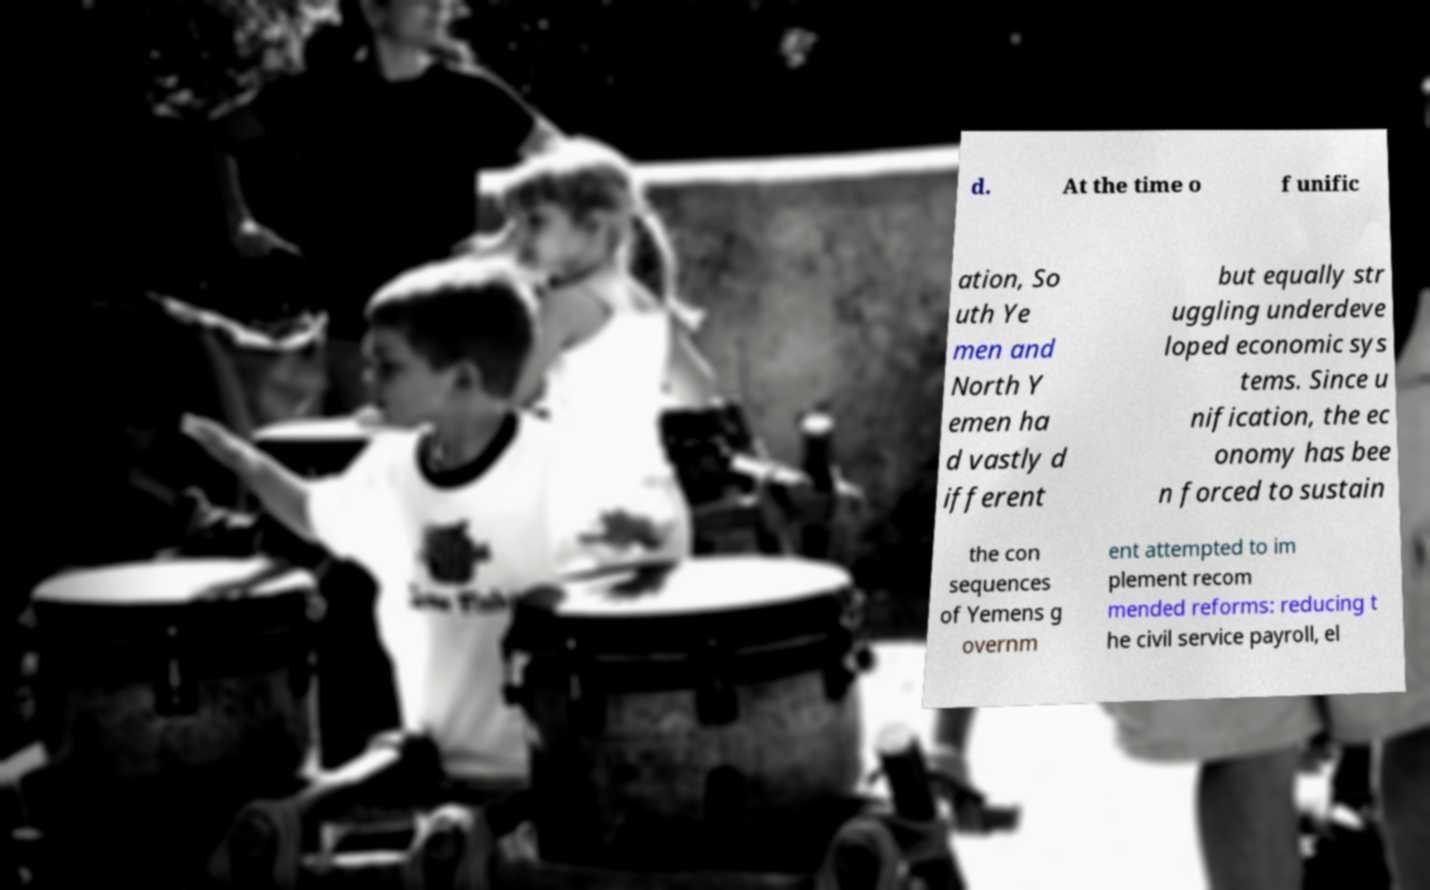Please identify and transcribe the text found in this image. d. At the time o f unific ation, So uth Ye men and North Y emen ha d vastly d ifferent but equally str uggling underdeve loped economic sys tems. Since u nification, the ec onomy has bee n forced to sustain the con sequences of Yemens g overnm ent attempted to im plement recom mended reforms: reducing t he civil service payroll, el 